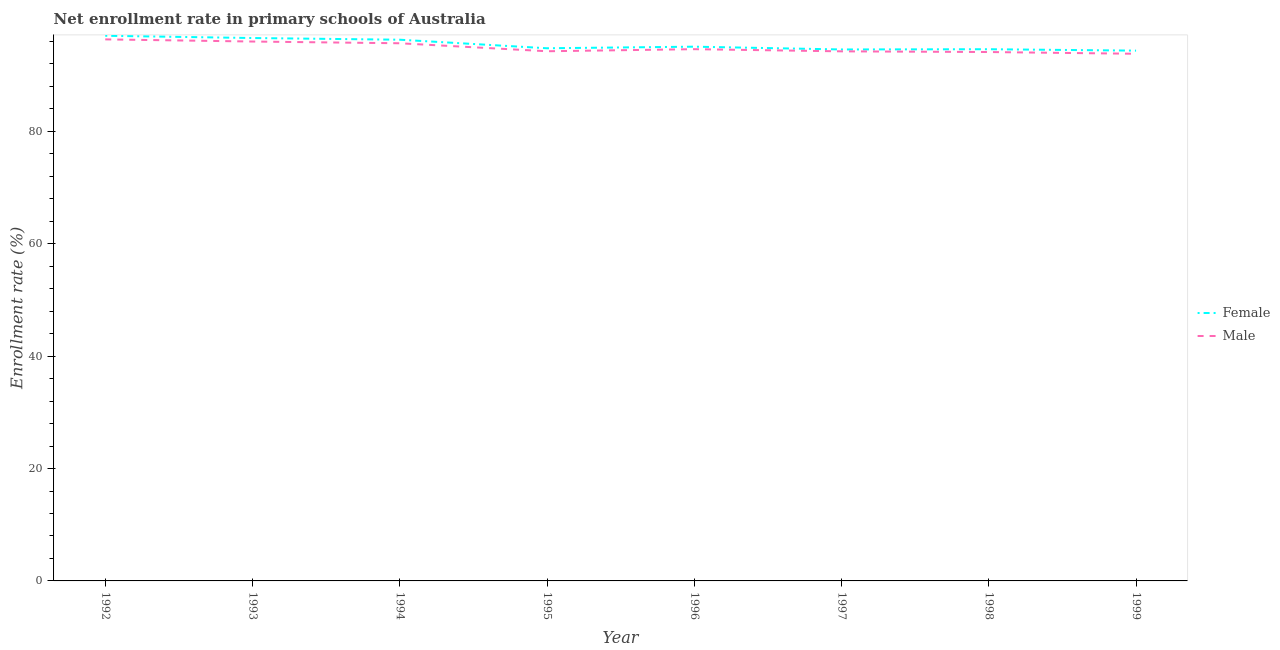Does the line corresponding to enrollment rate of female students intersect with the line corresponding to enrollment rate of male students?
Your answer should be very brief. No. Is the number of lines equal to the number of legend labels?
Your answer should be very brief. Yes. What is the enrollment rate of male students in 1998?
Provide a short and direct response. 94.13. Across all years, what is the maximum enrollment rate of male students?
Provide a succinct answer. 96.38. Across all years, what is the minimum enrollment rate of male students?
Keep it short and to the point. 93.82. In which year was the enrollment rate of male students minimum?
Offer a very short reply. 1999. What is the total enrollment rate of male students in the graph?
Provide a short and direct response. 759.17. What is the difference between the enrollment rate of male students in 1992 and that in 1995?
Your answer should be compact. 2.11. What is the difference between the enrollment rate of female students in 1994 and the enrollment rate of male students in 1999?
Your answer should be very brief. 2.5. What is the average enrollment rate of male students per year?
Offer a terse response. 94.9. In the year 1997, what is the difference between the enrollment rate of female students and enrollment rate of male students?
Provide a short and direct response. 0.33. In how many years, is the enrollment rate of female students greater than 44 %?
Keep it short and to the point. 8. What is the ratio of the enrollment rate of male students in 1998 to that in 1999?
Offer a terse response. 1. Is the enrollment rate of female students in 1993 less than that in 1994?
Your response must be concise. No. Is the difference between the enrollment rate of male students in 1998 and 1999 greater than the difference between the enrollment rate of female students in 1998 and 1999?
Offer a terse response. Yes. What is the difference between the highest and the second highest enrollment rate of female students?
Make the answer very short. 0.4. What is the difference between the highest and the lowest enrollment rate of male students?
Make the answer very short. 2.56. Does the enrollment rate of male students monotonically increase over the years?
Offer a terse response. No. How many years are there in the graph?
Offer a terse response. 8. Does the graph contain grids?
Ensure brevity in your answer.  No. Where does the legend appear in the graph?
Ensure brevity in your answer.  Center right. What is the title of the graph?
Offer a terse response. Net enrollment rate in primary schools of Australia. Does "Imports" appear as one of the legend labels in the graph?
Offer a terse response. No. What is the label or title of the X-axis?
Ensure brevity in your answer.  Year. What is the label or title of the Y-axis?
Your response must be concise. Enrollment rate (%). What is the Enrollment rate (%) of Female in 1992?
Your answer should be very brief. 97.02. What is the Enrollment rate (%) in Male in 1992?
Keep it short and to the point. 96.38. What is the Enrollment rate (%) of Female in 1993?
Make the answer very short. 96.62. What is the Enrollment rate (%) in Male in 1993?
Give a very brief answer. 96. What is the Enrollment rate (%) in Female in 1994?
Your answer should be compact. 96.32. What is the Enrollment rate (%) of Male in 1994?
Keep it short and to the point. 95.69. What is the Enrollment rate (%) of Female in 1995?
Your answer should be very brief. 94.8. What is the Enrollment rate (%) in Male in 1995?
Keep it short and to the point. 94.27. What is the Enrollment rate (%) of Female in 1996?
Give a very brief answer. 95.08. What is the Enrollment rate (%) of Male in 1996?
Make the answer very short. 94.64. What is the Enrollment rate (%) in Female in 1997?
Your answer should be very brief. 94.58. What is the Enrollment rate (%) in Male in 1997?
Provide a short and direct response. 94.25. What is the Enrollment rate (%) of Female in 1998?
Offer a very short reply. 94.63. What is the Enrollment rate (%) in Male in 1998?
Keep it short and to the point. 94.13. What is the Enrollment rate (%) in Female in 1999?
Provide a succinct answer. 94.38. What is the Enrollment rate (%) in Male in 1999?
Offer a very short reply. 93.82. Across all years, what is the maximum Enrollment rate (%) of Female?
Keep it short and to the point. 97.02. Across all years, what is the maximum Enrollment rate (%) in Male?
Ensure brevity in your answer.  96.38. Across all years, what is the minimum Enrollment rate (%) of Female?
Provide a succinct answer. 94.38. Across all years, what is the minimum Enrollment rate (%) of Male?
Ensure brevity in your answer.  93.82. What is the total Enrollment rate (%) of Female in the graph?
Keep it short and to the point. 763.44. What is the total Enrollment rate (%) in Male in the graph?
Keep it short and to the point. 759.17. What is the difference between the Enrollment rate (%) in Female in 1992 and that in 1993?
Provide a short and direct response. 0.4. What is the difference between the Enrollment rate (%) of Male in 1992 and that in 1993?
Your answer should be very brief. 0.38. What is the difference between the Enrollment rate (%) in Female in 1992 and that in 1994?
Give a very brief answer. 0.7. What is the difference between the Enrollment rate (%) of Male in 1992 and that in 1994?
Offer a terse response. 0.69. What is the difference between the Enrollment rate (%) in Female in 1992 and that in 1995?
Offer a terse response. 2.22. What is the difference between the Enrollment rate (%) in Male in 1992 and that in 1995?
Provide a short and direct response. 2.11. What is the difference between the Enrollment rate (%) of Female in 1992 and that in 1996?
Make the answer very short. 1.94. What is the difference between the Enrollment rate (%) of Male in 1992 and that in 1996?
Your response must be concise. 1.74. What is the difference between the Enrollment rate (%) of Female in 1992 and that in 1997?
Ensure brevity in your answer.  2.44. What is the difference between the Enrollment rate (%) of Male in 1992 and that in 1997?
Keep it short and to the point. 2.13. What is the difference between the Enrollment rate (%) in Female in 1992 and that in 1998?
Your response must be concise. 2.39. What is the difference between the Enrollment rate (%) of Male in 1992 and that in 1998?
Ensure brevity in your answer.  2.25. What is the difference between the Enrollment rate (%) of Female in 1992 and that in 1999?
Give a very brief answer. 2.64. What is the difference between the Enrollment rate (%) of Male in 1992 and that in 1999?
Provide a short and direct response. 2.56. What is the difference between the Enrollment rate (%) in Female in 1993 and that in 1994?
Make the answer very short. 0.3. What is the difference between the Enrollment rate (%) in Male in 1993 and that in 1994?
Your answer should be very brief. 0.31. What is the difference between the Enrollment rate (%) of Female in 1993 and that in 1995?
Your answer should be very brief. 1.82. What is the difference between the Enrollment rate (%) in Male in 1993 and that in 1995?
Your answer should be compact. 1.73. What is the difference between the Enrollment rate (%) of Female in 1993 and that in 1996?
Offer a very short reply. 1.54. What is the difference between the Enrollment rate (%) in Male in 1993 and that in 1996?
Keep it short and to the point. 1.36. What is the difference between the Enrollment rate (%) in Female in 1993 and that in 1997?
Ensure brevity in your answer.  2.04. What is the difference between the Enrollment rate (%) of Male in 1993 and that in 1997?
Provide a succinct answer. 1.75. What is the difference between the Enrollment rate (%) in Female in 1993 and that in 1998?
Ensure brevity in your answer.  1.99. What is the difference between the Enrollment rate (%) of Male in 1993 and that in 1998?
Offer a terse response. 1.87. What is the difference between the Enrollment rate (%) of Female in 1993 and that in 1999?
Your response must be concise. 2.25. What is the difference between the Enrollment rate (%) in Male in 1993 and that in 1999?
Your answer should be compact. 2.18. What is the difference between the Enrollment rate (%) of Female in 1994 and that in 1995?
Your response must be concise. 1.52. What is the difference between the Enrollment rate (%) in Male in 1994 and that in 1995?
Give a very brief answer. 1.42. What is the difference between the Enrollment rate (%) of Female in 1994 and that in 1996?
Provide a succinct answer. 1.24. What is the difference between the Enrollment rate (%) in Male in 1994 and that in 1996?
Your answer should be compact. 1.05. What is the difference between the Enrollment rate (%) in Female in 1994 and that in 1997?
Your response must be concise. 1.74. What is the difference between the Enrollment rate (%) of Male in 1994 and that in 1997?
Offer a very short reply. 1.44. What is the difference between the Enrollment rate (%) in Female in 1994 and that in 1998?
Offer a very short reply. 1.69. What is the difference between the Enrollment rate (%) of Male in 1994 and that in 1998?
Provide a short and direct response. 1.56. What is the difference between the Enrollment rate (%) of Female in 1994 and that in 1999?
Your answer should be very brief. 1.94. What is the difference between the Enrollment rate (%) of Male in 1994 and that in 1999?
Make the answer very short. 1.87. What is the difference between the Enrollment rate (%) of Female in 1995 and that in 1996?
Provide a short and direct response. -0.28. What is the difference between the Enrollment rate (%) of Male in 1995 and that in 1996?
Provide a short and direct response. -0.37. What is the difference between the Enrollment rate (%) of Female in 1995 and that in 1997?
Provide a short and direct response. 0.22. What is the difference between the Enrollment rate (%) in Male in 1995 and that in 1997?
Your response must be concise. 0.02. What is the difference between the Enrollment rate (%) in Female in 1995 and that in 1998?
Your answer should be very brief. 0.17. What is the difference between the Enrollment rate (%) of Male in 1995 and that in 1998?
Your response must be concise. 0.14. What is the difference between the Enrollment rate (%) in Female in 1995 and that in 1999?
Offer a very short reply. 0.42. What is the difference between the Enrollment rate (%) of Male in 1995 and that in 1999?
Your response must be concise. 0.45. What is the difference between the Enrollment rate (%) in Female in 1996 and that in 1997?
Provide a short and direct response. 0.5. What is the difference between the Enrollment rate (%) in Male in 1996 and that in 1997?
Offer a terse response. 0.38. What is the difference between the Enrollment rate (%) in Female in 1996 and that in 1998?
Provide a succinct answer. 0.45. What is the difference between the Enrollment rate (%) in Male in 1996 and that in 1998?
Your answer should be compact. 0.51. What is the difference between the Enrollment rate (%) of Female in 1996 and that in 1999?
Ensure brevity in your answer.  0.7. What is the difference between the Enrollment rate (%) of Male in 1996 and that in 1999?
Provide a short and direct response. 0.82. What is the difference between the Enrollment rate (%) of Female in 1997 and that in 1998?
Your response must be concise. -0.05. What is the difference between the Enrollment rate (%) in Male in 1997 and that in 1998?
Ensure brevity in your answer.  0.12. What is the difference between the Enrollment rate (%) in Female in 1997 and that in 1999?
Your answer should be very brief. 0.21. What is the difference between the Enrollment rate (%) in Male in 1997 and that in 1999?
Make the answer very short. 0.43. What is the difference between the Enrollment rate (%) in Female in 1998 and that in 1999?
Offer a terse response. 0.25. What is the difference between the Enrollment rate (%) of Male in 1998 and that in 1999?
Offer a very short reply. 0.31. What is the difference between the Enrollment rate (%) of Female in 1992 and the Enrollment rate (%) of Male in 1993?
Make the answer very short. 1.02. What is the difference between the Enrollment rate (%) of Female in 1992 and the Enrollment rate (%) of Male in 1994?
Your answer should be compact. 1.33. What is the difference between the Enrollment rate (%) of Female in 1992 and the Enrollment rate (%) of Male in 1995?
Ensure brevity in your answer.  2.75. What is the difference between the Enrollment rate (%) of Female in 1992 and the Enrollment rate (%) of Male in 1996?
Keep it short and to the point. 2.39. What is the difference between the Enrollment rate (%) in Female in 1992 and the Enrollment rate (%) in Male in 1997?
Your answer should be compact. 2.77. What is the difference between the Enrollment rate (%) of Female in 1992 and the Enrollment rate (%) of Male in 1998?
Keep it short and to the point. 2.89. What is the difference between the Enrollment rate (%) of Female in 1992 and the Enrollment rate (%) of Male in 1999?
Offer a very short reply. 3.2. What is the difference between the Enrollment rate (%) of Female in 1993 and the Enrollment rate (%) of Male in 1994?
Provide a succinct answer. 0.93. What is the difference between the Enrollment rate (%) of Female in 1993 and the Enrollment rate (%) of Male in 1995?
Your answer should be compact. 2.35. What is the difference between the Enrollment rate (%) in Female in 1993 and the Enrollment rate (%) in Male in 1996?
Your answer should be very brief. 1.99. What is the difference between the Enrollment rate (%) in Female in 1993 and the Enrollment rate (%) in Male in 1997?
Your answer should be compact. 2.37. What is the difference between the Enrollment rate (%) in Female in 1993 and the Enrollment rate (%) in Male in 1998?
Your answer should be very brief. 2.49. What is the difference between the Enrollment rate (%) of Female in 1993 and the Enrollment rate (%) of Male in 1999?
Provide a short and direct response. 2.8. What is the difference between the Enrollment rate (%) in Female in 1994 and the Enrollment rate (%) in Male in 1995?
Offer a terse response. 2.05. What is the difference between the Enrollment rate (%) in Female in 1994 and the Enrollment rate (%) in Male in 1996?
Offer a terse response. 1.68. What is the difference between the Enrollment rate (%) in Female in 1994 and the Enrollment rate (%) in Male in 1997?
Give a very brief answer. 2.07. What is the difference between the Enrollment rate (%) of Female in 1994 and the Enrollment rate (%) of Male in 1998?
Keep it short and to the point. 2.19. What is the difference between the Enrollment rate (%) in Female in 1994 and the Enrollment rate (%) in Male in 1999?
Your answer should be very brief. 2.5. What is the difference between the Enrollment rate (%) in Female in 1995 and the Enrollment rate (%) in Male in 1996?
Ensure brevity in your answer.  0.16. What is the difference between the Enrollment rate (%) in Female in 1995 and the Enrollment rate (%) in Male in 1997?
Provide a short and direct response. 0.55. What is the difference between the Enrollment rate (%) of Female in 1995 and the Enrollment rate (%) of Male in 1998?
Your answer should be very brief. 0.67. What is the difference between the Enrollment rate (%) in Female in 1995 and the Enrollment rate (%) in Male in 1999?
Provide a succinct answer. 0.98. What is the difference between the Enrollment rate (%) in Female in 1996 and the Enrollment rate (%) in Male in 1997?
Offer a terse response. 0.83. What is the difference between the Enrollment rate (%) in Female in 1996 and the Enrollment rate (%) in Male in 1998?
Keep it short and to the point. 0.95. What is the difference between the Enrollment rate (%) of Female in 1996 and the Enrollment rate (%) of Male in 1999?
Keep it short and to the point. 1.26. What is the difference between the Enrollment rate (%) of Female in 1997 and the Enrollment rate (%) of Male in 1998?
Keep it short and to the point. 0.46. What is the difference between the Enrollment rate (%) in Female in 1997 and the Enrollment rate (%) in Male in 1999?
Keep it short and to the point. 0.77. What is the difference between the Enrollment rate (%) of Female in 1998 and the Enrollment rate (%) of Male in 1999?
Your response must be concise. 0.81. What is the average Enrollment rate (%) of Female per year?
Provide a short and direct response. 95.43. What is the average Enrollment rate (%) in Male per year?
Ensure brevity in your answer.  94.9. In the year 1992, what is the difference between the Enrollment rate (%) of Female and Enrollment rate (%) of Male?
Provide a succinct answer. 0.64. In the year 1993, what is the difference between the Enrollment rate (%) in Female and Enrollment rate (%) in Male?
Your answer should be compact. 0.62. In the year 1994, what is the difference between the Enrollment rate (%) of Female and Enrollment rate (%) of Male?
Ensure brevity in your answer.  0.63. In the year 1995, what is the difference between the Enrollment rate (%) of Female and Enrollment rate (%) of Male?
Make the answer very short. 0.53. In the year 1996, what is the difference between the Enrollment rate (%) of Female and Enrollment rate (%) of Male?
Your answer should be very brief. 0.45. In the year 1997, what is the difference between the Enrollment rate (%) of Female and Enrollment rate (%) of Male?
Your answer should be very brief. 0.33. In the year 1998, what is the difference between the Enrollment rate (%) in Female and Enrollment rate (%) in Male?
Give a very brief answer. 0.5. In the year 1999, what is the difference between the Enrollment rate (%) of Female and Enrollment rate (%) of Male?
Your response must be concise. 0.56. What is the ratio of the Enrollment rate (%) of Female in 1992 to that in 1993?
Provide a succinct answer. 1. What is the ratio of the Enrollment rate (%) of Male in 1992 to that in 1993?
Provide a succinct answer. 1. What is the ratio of the Enrollment rate (%) in Female in 1992 to that in 1994?
Ensure brevity in your answer.  1.01. What is the ratio of the Enrollment rate (%) of Female in 1992 to that in 1995?
Your answer should be very brief. 1.02. What is the ratio of the Enrollment rate (%) in Male in 1992 to that in 1995?
Make the answer very short. 1.02. What is the ratio of the Enrollment rate (%) in Female in 1992 to that in 1996?
Ensure brevity in your answer.  1.02. What is the ratio of the Enrollment rate (%) of Male in 1992 to that in 1996?
Ensure brevity in your answer.  1.02. What is the ratio of the Enrollment rate (%) of Female in 1992 to that in 1997?
Give a very brief answer. 1.03. What is the ratio of the Enrollment rate (%) of Male in 1992 to that in 1997?
Your response must be concise. 1.02. What is the ratio of the Enrollment rate (%) in Female in 1992 to that in 1998?
Offer a terse response. 1.03. What is the ratio of the Enrollment rate (%) of Male in 1992 to that in 1998?
Your response must be concise. 1.02. What is the ratio of the Enrollment rate (%) in Female in 1992 to that in 1999?
Your response must be concise. 1.03. What is the ratio of the Enrollment rate (%) of Male in 1992 to that in 1999?
Your answer should be very brief. 1.03. What is the ratio of the Enrollment rate (%) in Female in 1993 to that in 1994?
Provide a short and direct response. 1. What is the ratio of the Enrollment rate (%) in Female in 1993 to that in 1995?
Keep it short and to the point. 1.02. What is the ratio of the Enrollment rate (%) in Male in 1993 to that in 1995?
Offer a very short reply. 1.02. What is the ratio of the Enrollment rate (%) in Female in 1993 to that in 1996?
Give a very brief answer. 1.02. What is the ratio of the Enrollment rate (%) in Male in 1993 to that in 1996?
Ensure brevity in your answer.  1.01. What is the ratio of the Enrollment rate (%) in Female in 1993 to that in 1997?
Provide a short and direct response. 1.02. What is the ratio of the Enrollment rate (%) of Male in 1993 to that in 1997?
Offer a terse response. 1.02. What is the ratio of the Enrollment rate (%) in Female in 1993 to that in 1998?
Make the answer very short. 1.02. What is the ratio of the Enrollment rate (%) of Male in 1993 to that in 1998?
Keep it short and to the point. 1.02. What is the ratio of the Enrollment rate (%) of Female in 1993 to that in 1999?
Your answer should be very brief. 1.02. What is the ratio of the Enrollment rate (%) of Male in 1993 to that in 1999?
Give a very brief answer. 1.02. What is the ratio of the Enrollment rate (%) in Female in 1994 to that in 1995?
Make the answer very short. 1.02. What is the ratio of the Enrollment rate (%) of Male in 1994 to that in 1995?
Your response must be concise. 1.02. What is the ratio of the Enrollment rate (%) of Female in 1994 to that in 1996?
Ensure brevity in your answer.  1.01. What is the ratio of the Enrollment rate (%) in Male in 1994 to that in 1996?
Ensure brevity in your answer.  1.01. What is the ratio of the Enrollment rate (%) of Female in 1994 to that in 1997?
Make the answer very short. 1.02. What is the ratio of the Enrollment rate (%) in Male in 1994 to that in 1997?
Your answer should be compact. 1.02. What is the ratio of the Enrollment rate (%) of Female in 1994 to that in 1998?
Make the answer very short. 1.02. What is the ratio of the Enrollment rate (%) in Male in 1994 to that in 1998?
Your answer should be very brief. 1.02. What is the ratio of the Enrollment rate (%) of Female in 1994 to that in 1999?
Your response must be concise. 1.02. What is the ratio of the Enrollment rate (%) of Male in 1994 to that in 1999?
Provide a short and direct response. 1.02. What is the ratio of the Enrollment rate (%) of Female in 1995 to that in 1997?
Give a very brief answer. 1. What is the ratio of the Enrollment rate (%) in Female in 1995 to that in 1998?
Provide a succinct answer. 1. What is the ratio of the Enrollment rate (%) in Female in 1995 to that in 1999?
Offer a terse response. 1. What is the ratio of the Enrollment rate (%) of Male in 1995 to that in 1999?
Provide a succinct answer. 1. What is the ratio of the Enrollment rate (%) in Female in 1996 to that in 1998?
Provide a short and direct response. 1. What is the ratio of the Enrollment rate (%) in Male in 1996 to that in 1998?
Make the answer very short. 1.01. What is the ratio of the Enrollment rate (%) of Female in 1996 to that in 1999?
Your response must be concise. 1.01. What is the ratio of the Enrollment rate (%) in Male in 1996 to that in 1999?
Your answer should be very brief. 1.01. What is the ratio of the Enrollment rate (%) of Female in 1997 to that in 1998?
Offer a very short reply. 1. What is the ratio of the Enrollment rate (%) of Male in 1997 to that in 1999?
Your answer should be compact. 1. What is the ratio of the Enrollment rate (%) of Male in 1998 to that in 1999?
Give a very brief answer. 1. What is the difference between the highest and the second highest Enrollment rate (%) of Female?
Make the answer very short. 0.4. What is the difference between the highest and the second highest Enrollment rate (%) of Male?
Your answer should be very brief. 0.38. What is the difference between the highest and the lowest Enrollment rate (%) in Female?
Keep it short and to the point. 2.64. What is the difference between the highest and the lowest Enrollment rate (%) in Male?
Your answer should be very brief. 2.56. 